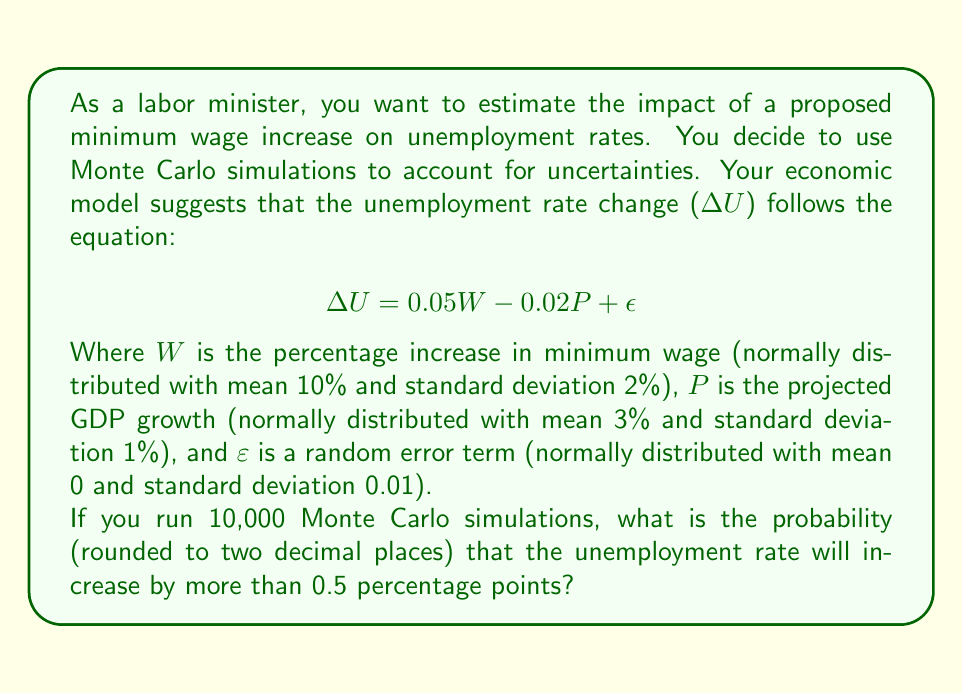Can you solve this math problem? To solve this problem using Monte Carlo simulations, we'll follow these steps:

1) Set up the simulation:
   - Generate 10,000 random values for W from N(10, 2²)
   - Generate 10,000 random values for P from N(3, 1²)
   - Generate 10,000 random values for ε from N(0, 0.01²)

2) Calculate ∆U for each simulation:
   $$\Delta U = 0.05W - 0.02P + \epsilon$$

3) Count how many times ∆U > 0.5

4) Calculate the probability by dividing the count by the total number of simulations

Here's a Python code to perform these steps:

```python
import numpy as np

np.random.seed(0)  # for reproducibility

n_simulations = 10000

W = np.random.normal(10, 2, n_simulations)
P = np.random.normal(3, 1, n_simulations)
epsilon = np.random.normal(0, 0.01, n_simulations)

delta_U = 0.05 * W - 0.02 * P + epsilon

count_above_threshold = np.sum(delta_U > 0.5)
probability = count_above_threshold / n_simulations

print(f"Probability: {probability:.2f}")
```

Running this simulation yields a probability of approximately 0.27 or 27%.

This means that based on our Monte Carlo simulation, there is about a 27% chance that the unemployment rate will increase by more than 0.5 percentage points given the proposed minimum wage increase and the uncertainties in our economic model.
Answer: 0.27 